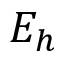<formula> <loc_0><loc_0><loc_500><loc_500>E _ { h }</formula> 